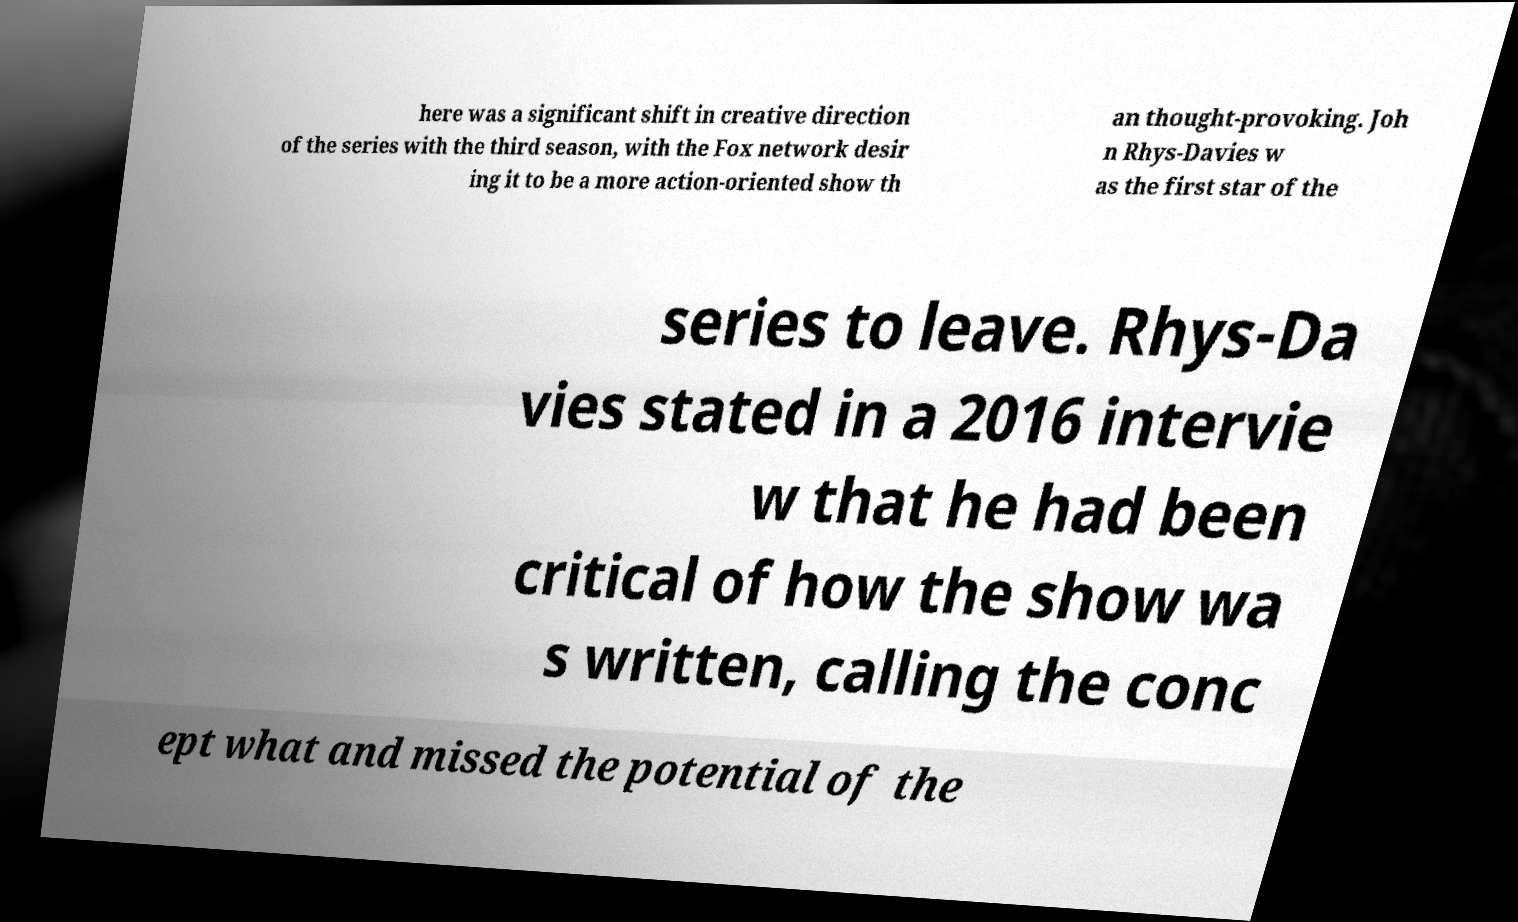Could you assist in decoding the text presented in this image and type it out clearly? here was a significant shift in creative direction of the series with the third season, with the Fox network desir ing it to be a more action-oriented show th an thought-provoking. Joh n Rhys-Davies w as the first star of the series to leave. Rhys-Da vies stated in a 2016 intervie w that he had been critical of how the show wa s written, calling the conc ept what and missed the potential of the 